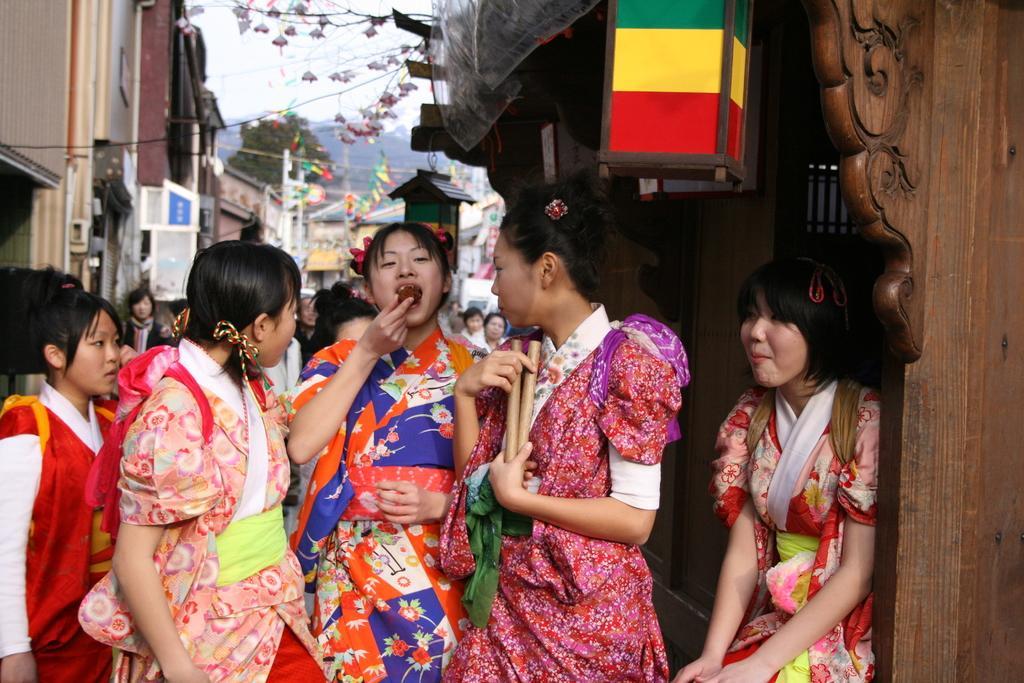How would you summarize this image in a sentence or two? In the foreground of the picture we can see a group of women standing, they are in traditional costumes. Towards right there is a wooden construction and there are wooden objects. In the background there are houses, ribbons, trees, flowers, people and various objects. At the top it is sky. 